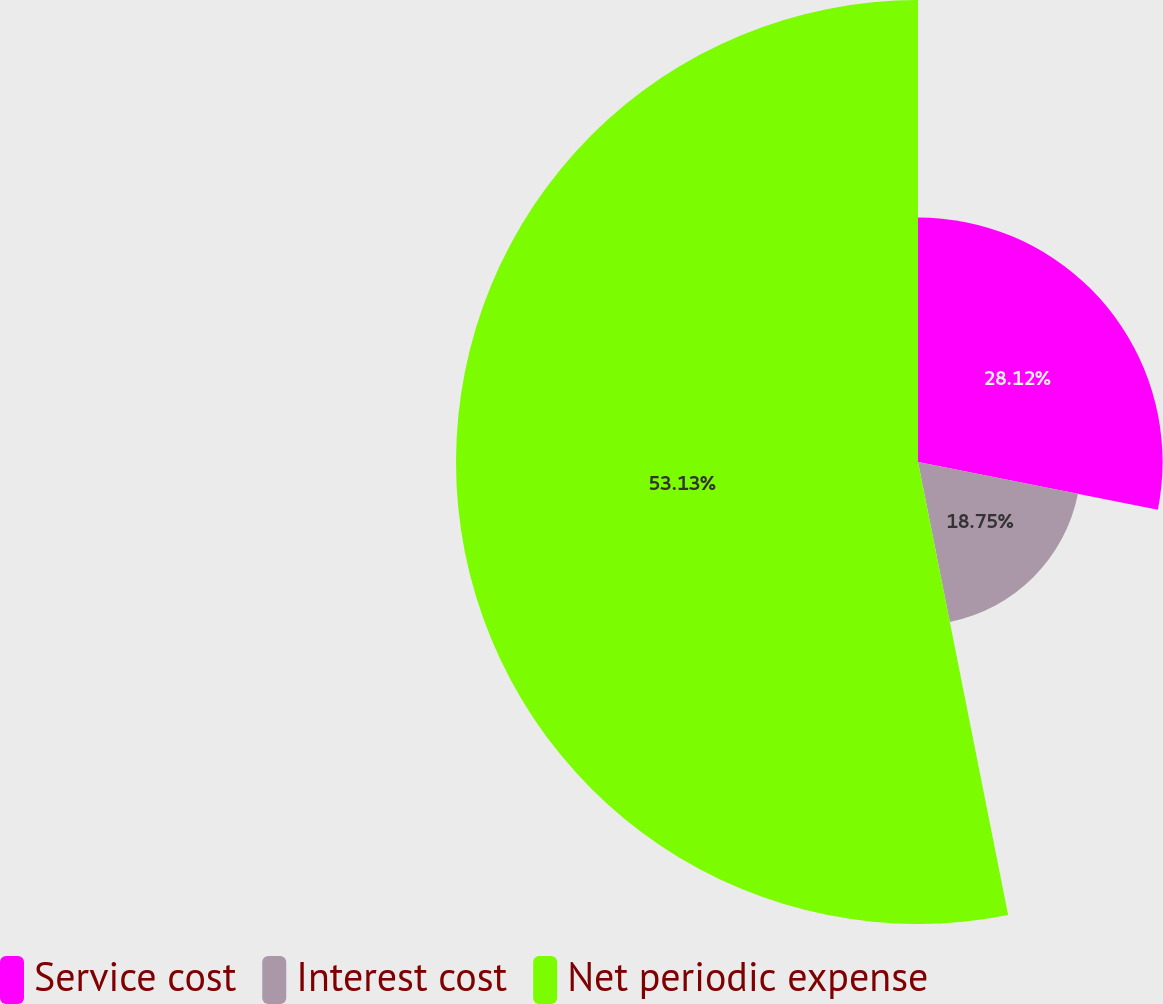<chart> <loc_0><loc_0><loc_500><loc_500><pie_chart><fcel>Service cost<fcel>Interest cost<fcel>Net periodic expense<nl><fcel>28.12%<fcel>18.75%<fcel>53.12%<nl></chart> 